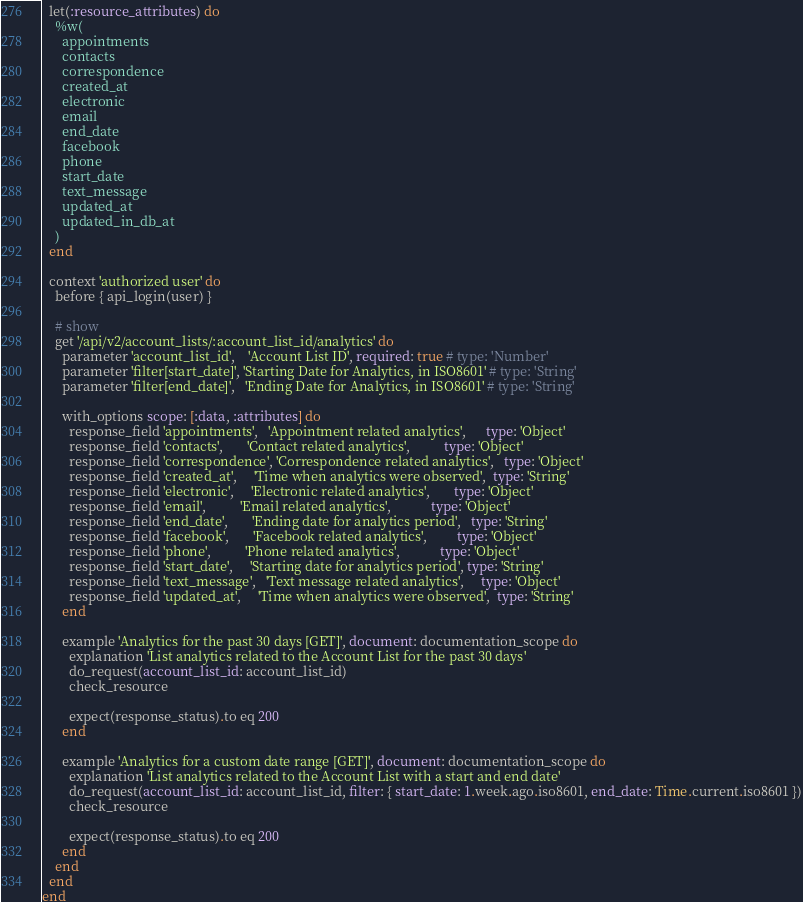Convert code to text. <code><loc_0><loc_0><loc_500><loc_500><_Ruby_>
  let(:resource_attributes) do
    %w(
      appointments
      contacts
      correspondence
      created_at
      electronic
      email
      end_date
      facebook
      phone
      start_date
      text_message
      updated_at
      updated_in_db_at
    )
  end

  context 'authorized user' do
    before { api_login(user) }

    # show
    get '/api/v2/account_lists/:account_list_id/analytics' do
      parameter 'account_list_id',    'Account List ID', required: true # type: 'Number'
      parameter 'filter[start_date]', 'Starting Date for Analytics, in ISO8601' # type: 'String'
      parameter 'filter[end_date]',   'Ending Date for Analytics, in ISO8601' # type: 'String'

      with_options scope: [:data, :attributes] do
        response_field 'appointments',   'Appointment related analytics',      type: 'Object'
        response_field 'contacts',       'Contact related analytics',          type: 'Object'
        response_field 'correspondence', 'Correspondence related analytics',   type: 'Object'
        response_field 'created_at',     'Time when analytics were observed',  type: 'String'
        response_field 'electronic',     'Electronic related analytics',       type: 'Object'
        response_field 'email',          'Email related analytics',            type: 'Object'
        response_field 'end_date',       'Ending date for analytics period',   type: 'String'
        response_field 'facebook',       'Facebook related analytics',         type: 'Object'
        response_field 'phone',          'Phone related analytics',            type: 'Object'
        response_field 'start_date',     'Starting date for analytics period', type: 'String'
        response_field 'text_message',   'Text message related analytics',     type: 'Object'
        response_field 'updated_at',     'Time when analytics were observed',  type: 'String'
      end

      example 'Analytics for the past 30 days [GET]', document: documentation_scope do
        explanation 'List analytics related to the Account List for the past 30 days'
        do_request(account_list_id: account_list_id)
        check_resource

        expect(response_status).to eq 200
      end

      example 'Analytics for a custom date range [GET]', document: documentation_scope do
        explanation 'List analytics related to the Account List with a start and end date'
        do_request(account_list_id: account_list_id, filter: { start_date: 1.week.ago.iso8601, end_date: Time.current.iso8601 })
        check_resource

        expect(response_status).to eq 200
      end
    end
  end
end
</code> 